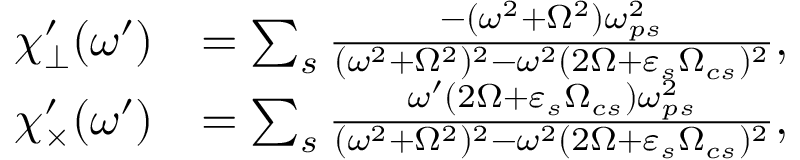<formula> <loc_0><loc_0><loc_500><loc_500>\begin{array} { r l } { \chi _ { \perp } ^ { \prime } ( \omega ^ { \prime } ) } & { = \sum _ { s } \frac { - ( \omega ^ { 2 } + \Omega ^ { 2 } ) \omega _ { p s } ^ { 2 } } { ( \omega ^ { 2 } + \Omega ^ { 2 } ) ^ { 2 } - \omega ^ { 2 } ( 2 \Omega + \varepsilon _ { s } \Omega _ { c s } ) ^ { 2 } } , } \\ { \chi _ { \times } ^ { \prime } ( \omega ^ { \prime } ) } & { = \sum _ { s } \frac { \omega ^ { \prime } ( 2 \Omega + \varepsilon _ { s } \Omega _ { c s } ) \omega _ { p s } ^ { 2 } } { ( \omega ^ { 2 } + \Omega ^ { 2 } ) ^ { 2 } - \omega ^ { 2 } ( 2 \Omega + \varepsilon _ { s } \Omega _ { c s } ) ^ { 2 } } , } \end{array}</formula> 